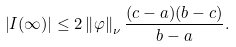<formula> <loc_0><loc_0><loc_500><loc_500>\left | I ( \infty ) \right | \leq 2 \left \| \varphi \right \| _ { \nu } \frac { ( c - a ) ( b - c ) } { b - a } .</formula> 